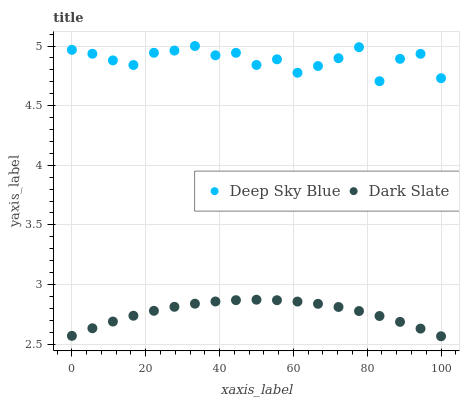Does Dark Slate have the minimum area under the curve?
Answer yes or no. Yes. Does Deep Sky Blue have the maximum area under the curve?
Answer yes or no. Yes. Does Deep Sky Blue have the minimum area under the curve?
Answer yes or no. No. Is Dark Slate the smoothest?
Answer yes or no. Yes. Is Deep Sky Blue the roughest?
Answer yes or no. Yes. Is Deep Sky Blue the smoothest?
Answer yes or no. No. Does Dark Slate have the lowest value?
Answer yes or no. Yes. Does Deep Sky Blue have the lowest value?
Answer yes or no. No. Does Deep Sky Blue have the highest value?
Answer yes or no. Yes. Is Dark Slate less than Deep Sky Blue?
Answer yes or no. Yes. Is Deep Sky Blue greater than Dark Slate?
Answer yes or no. Yes. Does Dark Slate intersect Deep Sky Blue?
Answer yes or no. No. 